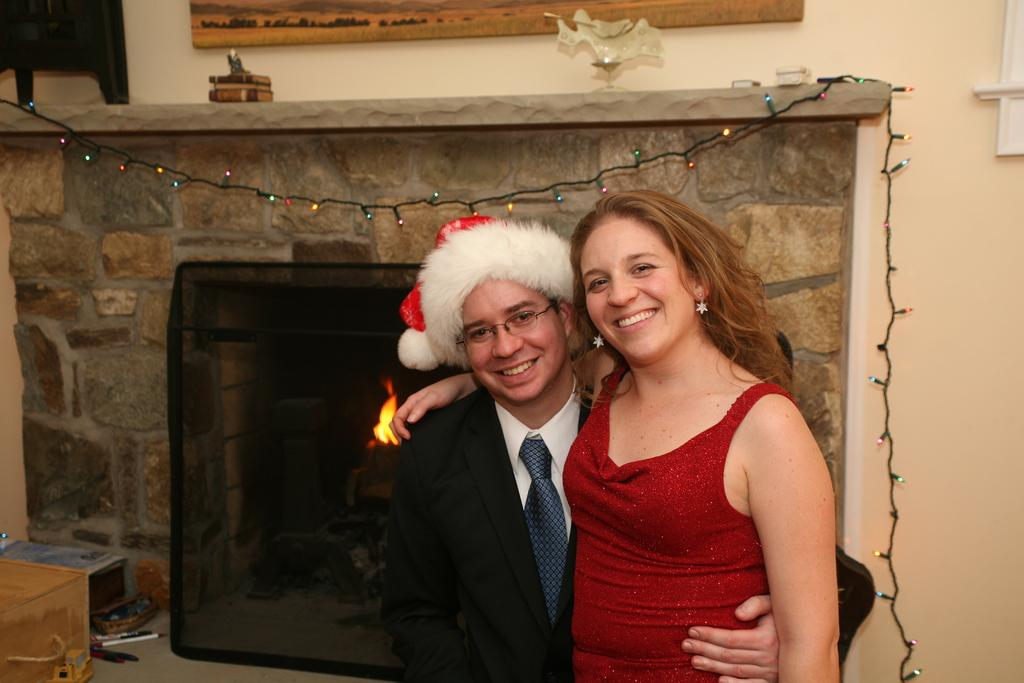What is the man wearing in the image? The man is wearing a Santa cap in the image. Who else is present in the image? There is a woman in the image. Where are the man and the woman located in the image? Both the man and the woman are standing in the foreground area of the image. What can be seen in the background of the image? There is a building, fire, and colorful lights visible in the background of the image. What type of industry is represented by the building in the image? There is no indication of the type of industry represented by the building in the image. How many clocks can be seen in the image? There are no clocks visible in the image. 